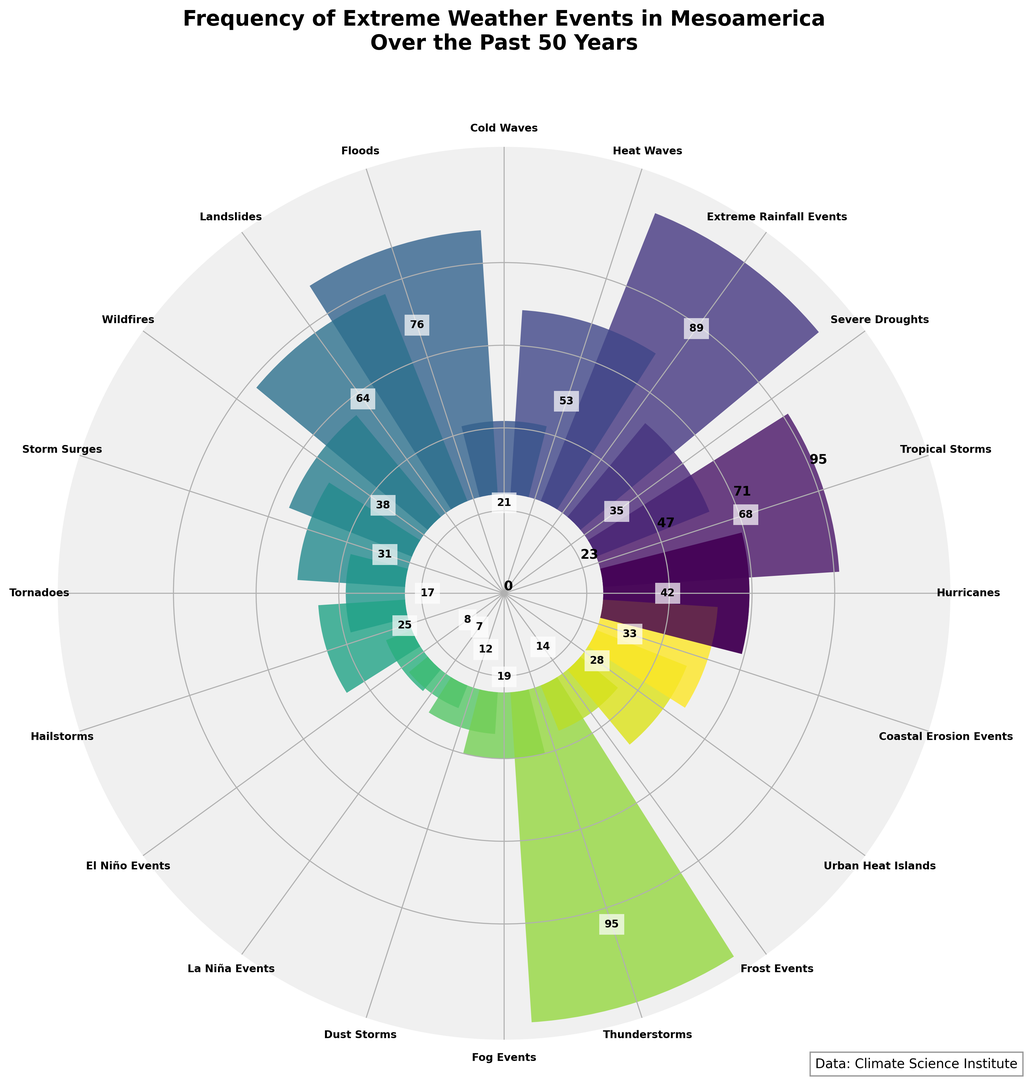Which type of extreme weather event has the highest frequency? From the plot, the bar with the highest value represents the frequency of extreme weather events. The bar with the highest value corresponds to "Thunderstorms".
Answer: Thunderstorms What is the combined frequency of Hurricanes and Tropical Storms? From the plot, the bar for Hurricanes shows a frequency of 42, and the bar for Tropical Storms shows a frequency of 68. Summing these two values gives 42 + 68 = 110.
Answer: 110 How does the frequency of Floods compare to the frequency of Landslides? From the plot, the bar for Floods shows a frequency of 76, and the bar for Landslides shows a frequency of 64. Comparing these values, Floods have a higher frequency than Landslides.
Answer: Floods have a higher frequency Which type of extreme weather event has the least frequency? From the plot, the bar with the smallest value represents the frequency of extreme weather events. The bar with the smallest value corresponds to "La Niña Events".
Answer: La Niña Events What is the difference in frequency between Heat Waves and Cold Waves? From the plot, the bar for Heat Waves shows a frequency of 53, and the bar for Cold Waves shows a frequency of 21. The difference is 53 - 21 = 32.
Answer: 32 Which event is more frequent, Wildfires or Storm Surges, and by how much? From the plot, the bar for Wildfires shows a frequency of 38, and the bar for Storm Surges shows a frequency of 31. Wildfires are more frequent by 38 - 31 = 7.
Answer: Wildfires by 7 How many types of extreme weather events have a frequency greater than 50? From the plot, the events with frequencies greater than 50 are Thunderstorms (95), Extreme Rainfall Events (89), Floods (76), Tropical Storms (68), and Heat Waves (53). The total count is 5.
Answer: 5 What is the median frequency value of extreme weather events shown in the plot? From the plot, we arrange the frequency values in ascending order: 7, 8, 12, 14, 17, 19, 21, 25, 28, 31, 33, 35, 38, 42, 53, 64, 68, 76, 89, 95. The median value is the average of the 10th and 11th values: (31 + 33) / 2 = 32.
Answer: 32 Which weather events appear to have a similar frequency visually, and what is that frequency? From the plot, Dust Storms and Fog Events have bars of similar height. Both bars show frequencies visually close to 12 and 19, respectively, but they look visually similar.
Answer: Dust Storms and Fog Events around 15 